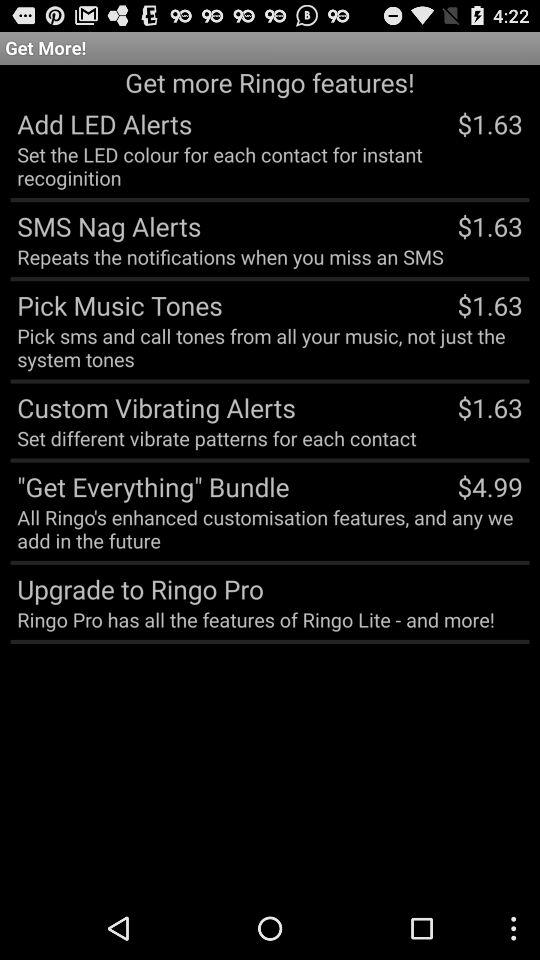What is the price of the Get Everything bundle? The price of the Get Everything bundle is $4.99. 